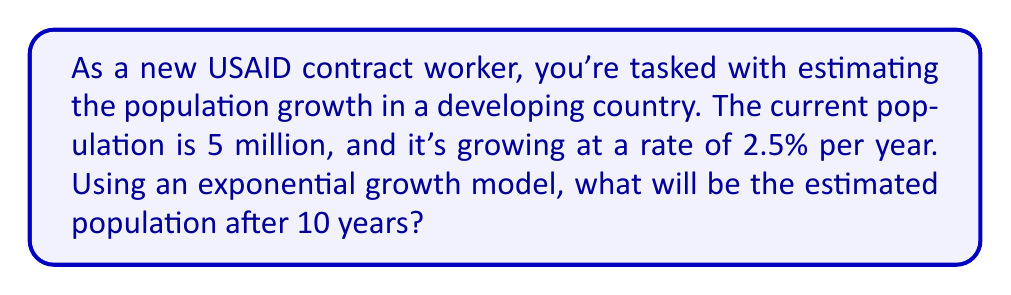Solve this math problem. Let's approach this step-by-step using the exponential growth model:

1. The exponential growth model is given by the formula:
   $$P(t) = P_0 \cdot e^{rt}$$
   Where:
   $P(t)$ is the population at time $t$
   $P_0$ is the initial population
   $r$ is the growth rate (as a decimal)
   $t$ is the time period
   $e$ is Euler's number (approximately 2.71828)

2. We have the following information:
   $P_0 = 5,000,000$ (initial population)
   $r = 0.025$ (2.5% growth rate as a decimal)
   $t = 10$ years

3. Let's substitute these values into the formula:
   $$P(10) = 5,000,000 \cdot e^{0.025 \cdot 10}$$

4. Simplify the exponent:
   $$P(10) = 5,000,000 \cdot e^{0.25}$$

5. Calculate $e^{0.25}$ (you can use a calculator for this):
   $$e^{0.25} \approx 1.2840$$

6. Multiply:
   $$P(10) = 5,000,000 \cdot 1.2840 \approx 6,420,000$$

Therefore, the estimated population after 10 years will be approximately 6,420,000 people.
Answer: 6,420,000 people 